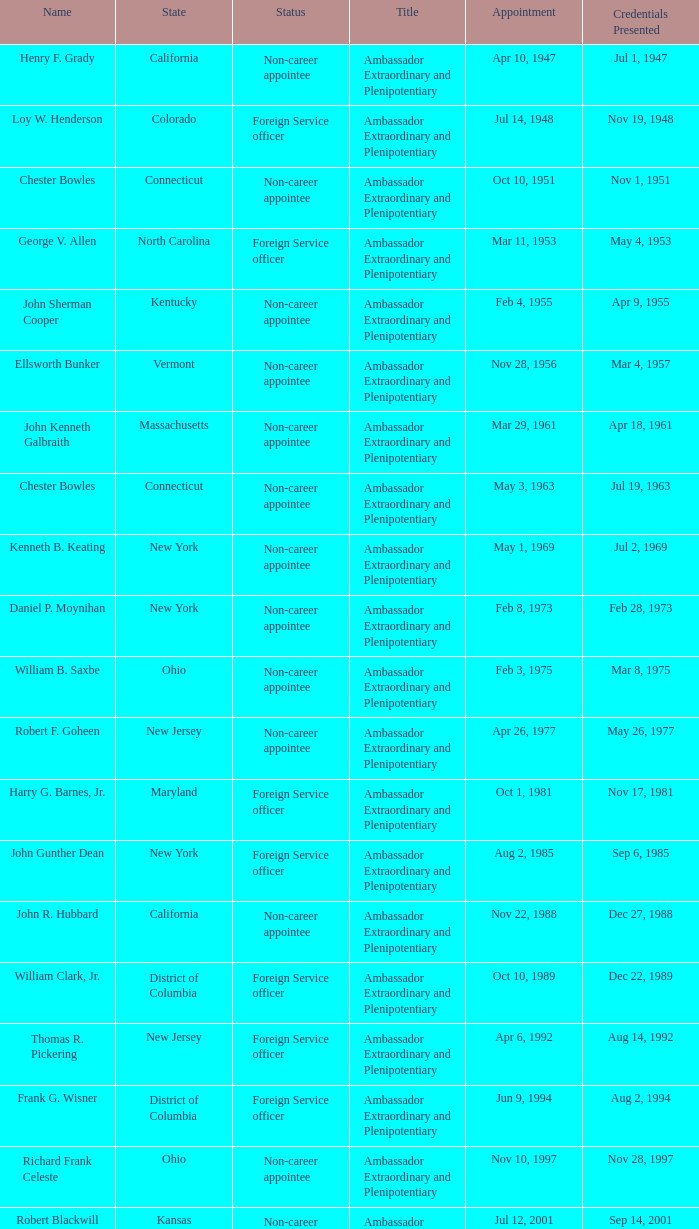When were the credentials presented for new jersey with a status of foreign service officer? Aug 14, 1992. 